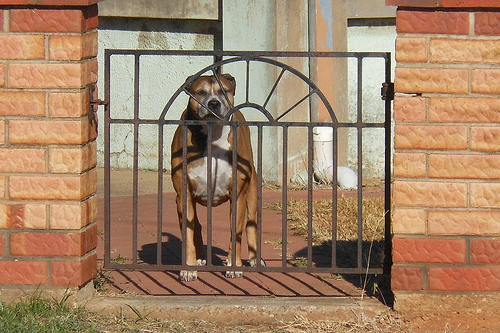<image>
Can you confirm if the dog is on the wall? No. The dog is not positioned on the wall. They may be near each other, but the dog is not supported by or resting on top of the wall. Is the dog to the left of the gate? No. The dog is not to the left of the gate. From this viewpoint, they have a different horizontal relationship. Is there a dog behind the gate? Yes. From this viewpoint, the dog is positioned behind the gate, with the gate partially or fully occluding the dog. 